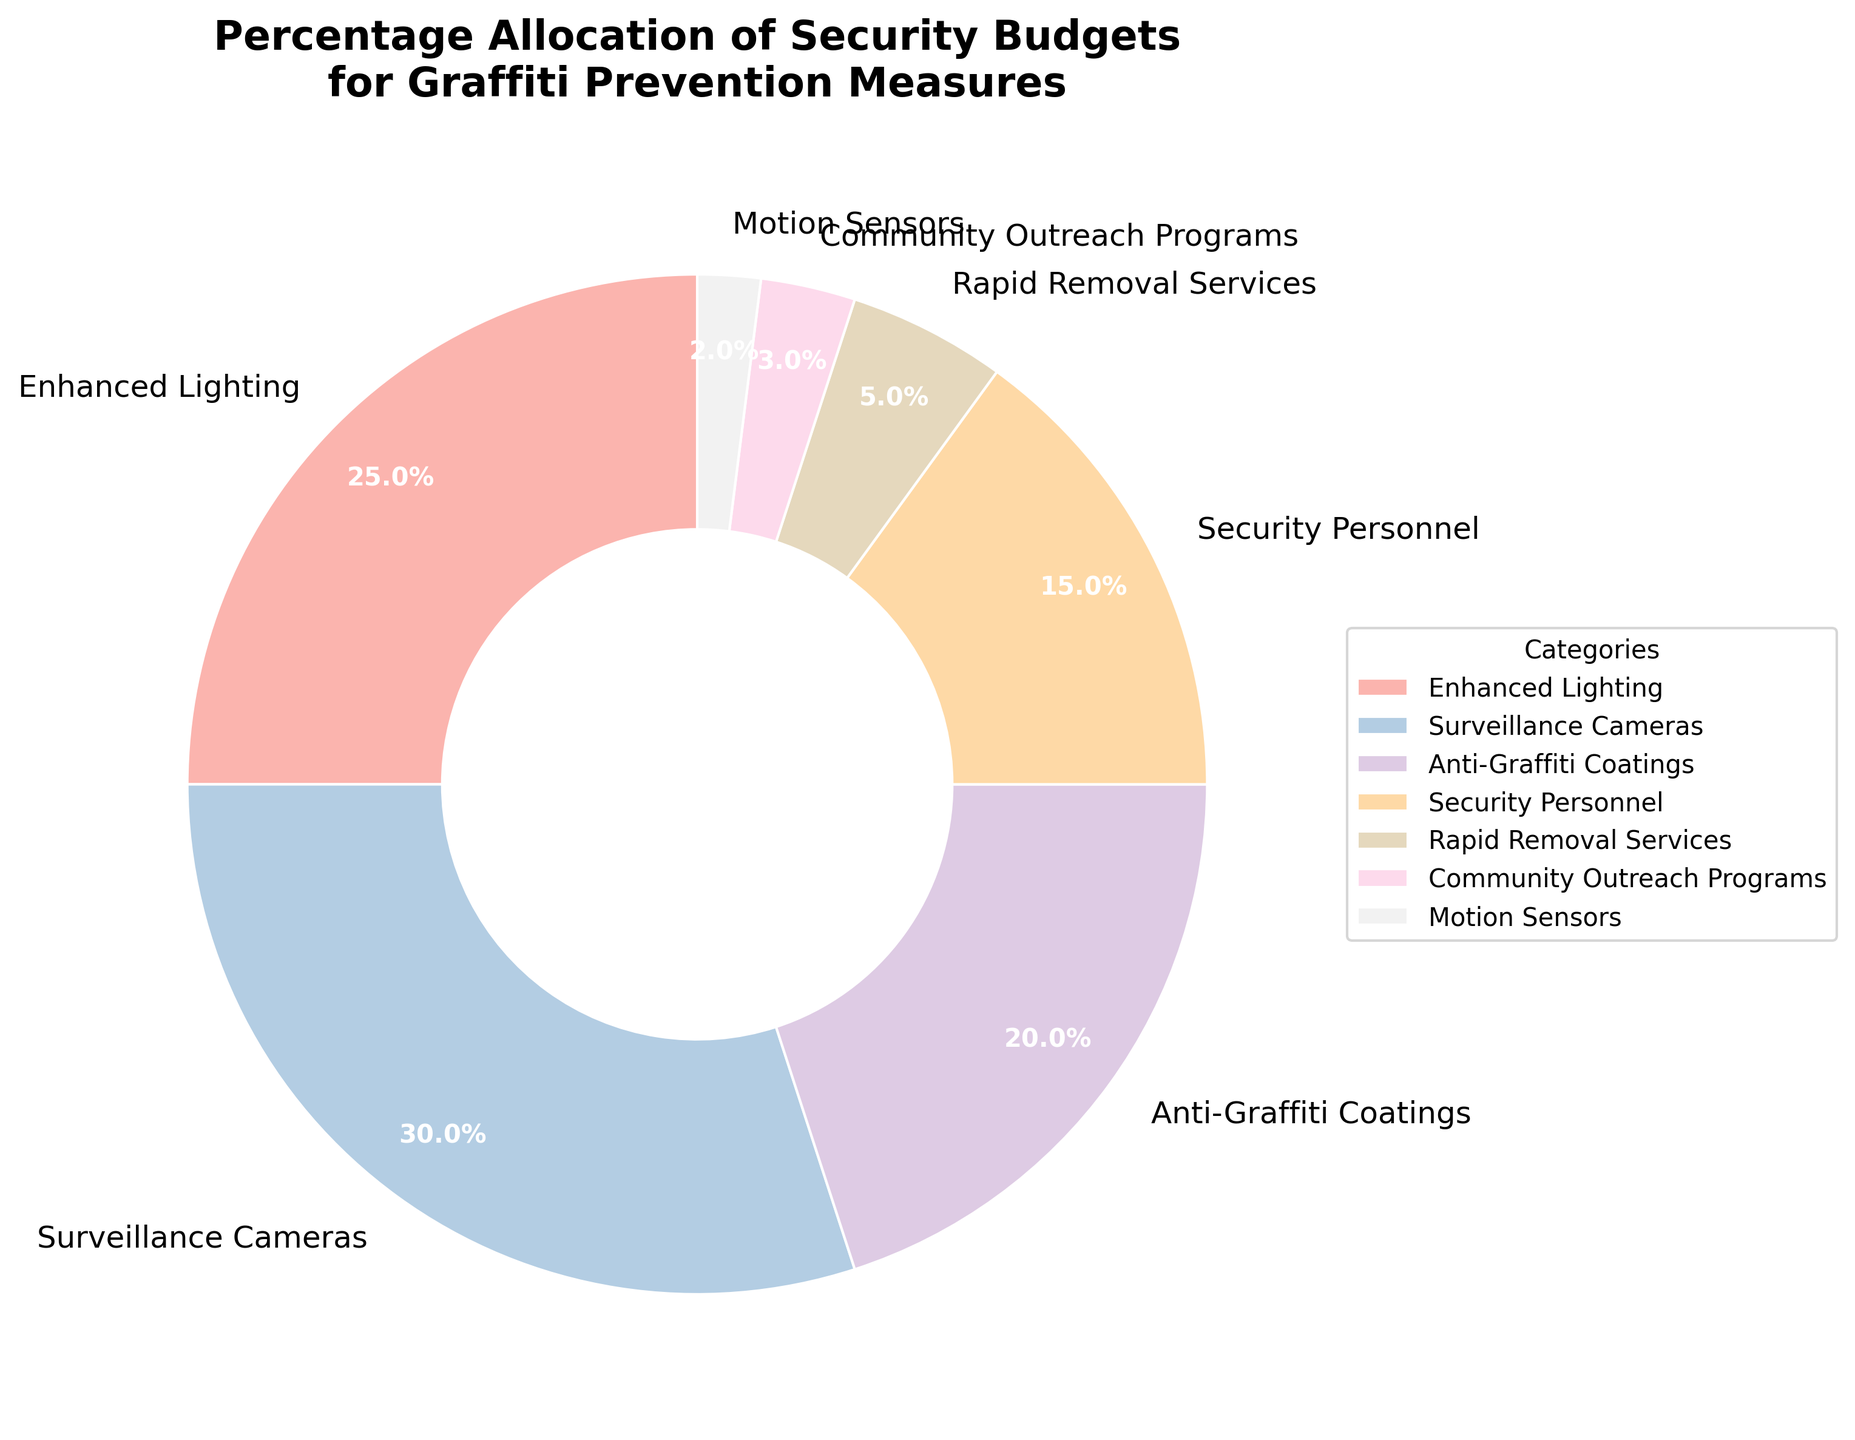What percentage of the budget is allocated to Surveillance Cameras? Looking at the pie chart, locate the section labeled 'Surveillance Cameras' and read the percentage value associated with it.
Answer: 30% Which measure has the smallest percentage allocation? Identify the section of the pie chart with the smallest wedge and read the label associated with it.
Answer: Motion Sensors How much more budget is allocated to Enhanced Lighting compared to Rapid Removal Services? Find the percentages allocated to both 'Enhanced Lighting' and 'Rapid Removal Services'. Subtract the smaller percentage from the larger one: 25% - 5% = 20%.
Answer: 20% What is the combined percentage allocation of Anti-Graffiti Coatings and Security Personnel? Locate the wedges labeled 'Anti-Graffiti Coatings' and 'Security Personnel'. Add their percentages together: 20% + 15% = 35%.
Answer: 35% Which two measures have a combined allocation that equals to the budget for Surveillance Cameras? Compare the percentages of individual measures and find the two whose sum equals the percentage for 'Surveillance Cameras': Anti-Graffiti Coatings (20%) + Security Personnel (15%) = 35%. This is a mistake as the Surveillance Cameras have 30%. Instead, combine other measures. For example, Enhanced Lighting (25%) and Rapid Removal Services (5%) = 30%.
Answer: Enhanced Lighting and Rapid Removal Services What is the difference in percentage allocation between Community Outreach Programs and Motion Sensors? Find the percentages allocated to 'Community Outreach Programs' and 'Motion Sensors'. Subtract the smaller percentage from the larger one: 3% - 2% = 1%.
Answer: 1% What proportion of the budget is allocated to measures related to direct physical monitoring (Surveillance Cameras and Security Personnel)? Add the percentages for 'Surveillance Cameras' and 'Security Personnel': 30% + 15% = 45%.
Answer: 45% Is the budget for Enhanced Lighting greater than the budget for Anti-Graffiti Coatings? Compare the percentage values for 'Enhanced Lighting' (25%) and 'Anti-Graffiti Coatings' (20%). 25% is greater than 20%.
Answer: Yes 